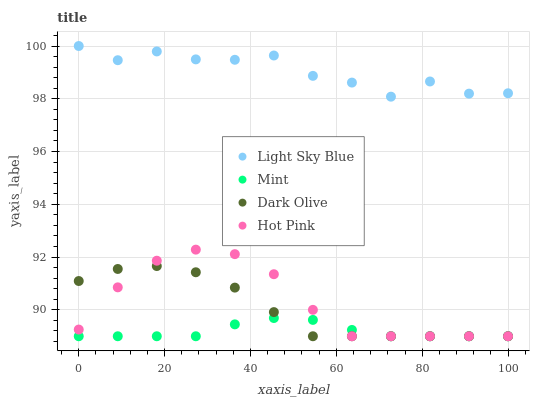Does Mint have the minimum area under the curve?
Answer yes or no. Yes. Does Light Sky Blue have the maximum area under the curve?
Answer yes or no. Yes. Does Light Sky Blue have the minimum area under the curve?
Answer yes or no. No. Does Mint have the maximum area under the curve?
Answer yes or no. No. Is Mint the smoothest?
Answer yes or no. Yes. Is Light Sky Blue the roughest?
Answer yes or no. Yes. Is Light Sky Blue the smoothest?
Answer yes or no. No. Is Mint the roughest?
Answer yes or no. No. Does Dark Olive have the lowest value?
Answer yes or no. Yes. Does Light Sky Blue have the lowest value?
Answer yes or no. No. Does Light Sky Blue have the highest value?
Answer yes or no. Yes. Does Mint have the highest value?
Answer yes or no. No. Is Mint less than Light Sky Blue?
Answer yes or no. Yes. Is Light Sky Blue greater than Dark Olive?
Answer yes or no. Yes. Does Hot Pink intersect Dark Olive?
Answer yes or no. Yes. Is Hot Pink less than Dark Olive?
Answer yes or no. No. Is Hot Pink greater than Dark Olive?
Answer yes or no. No. Does Mint intersect Light Sky Blue?
Answer yes or no. No. 